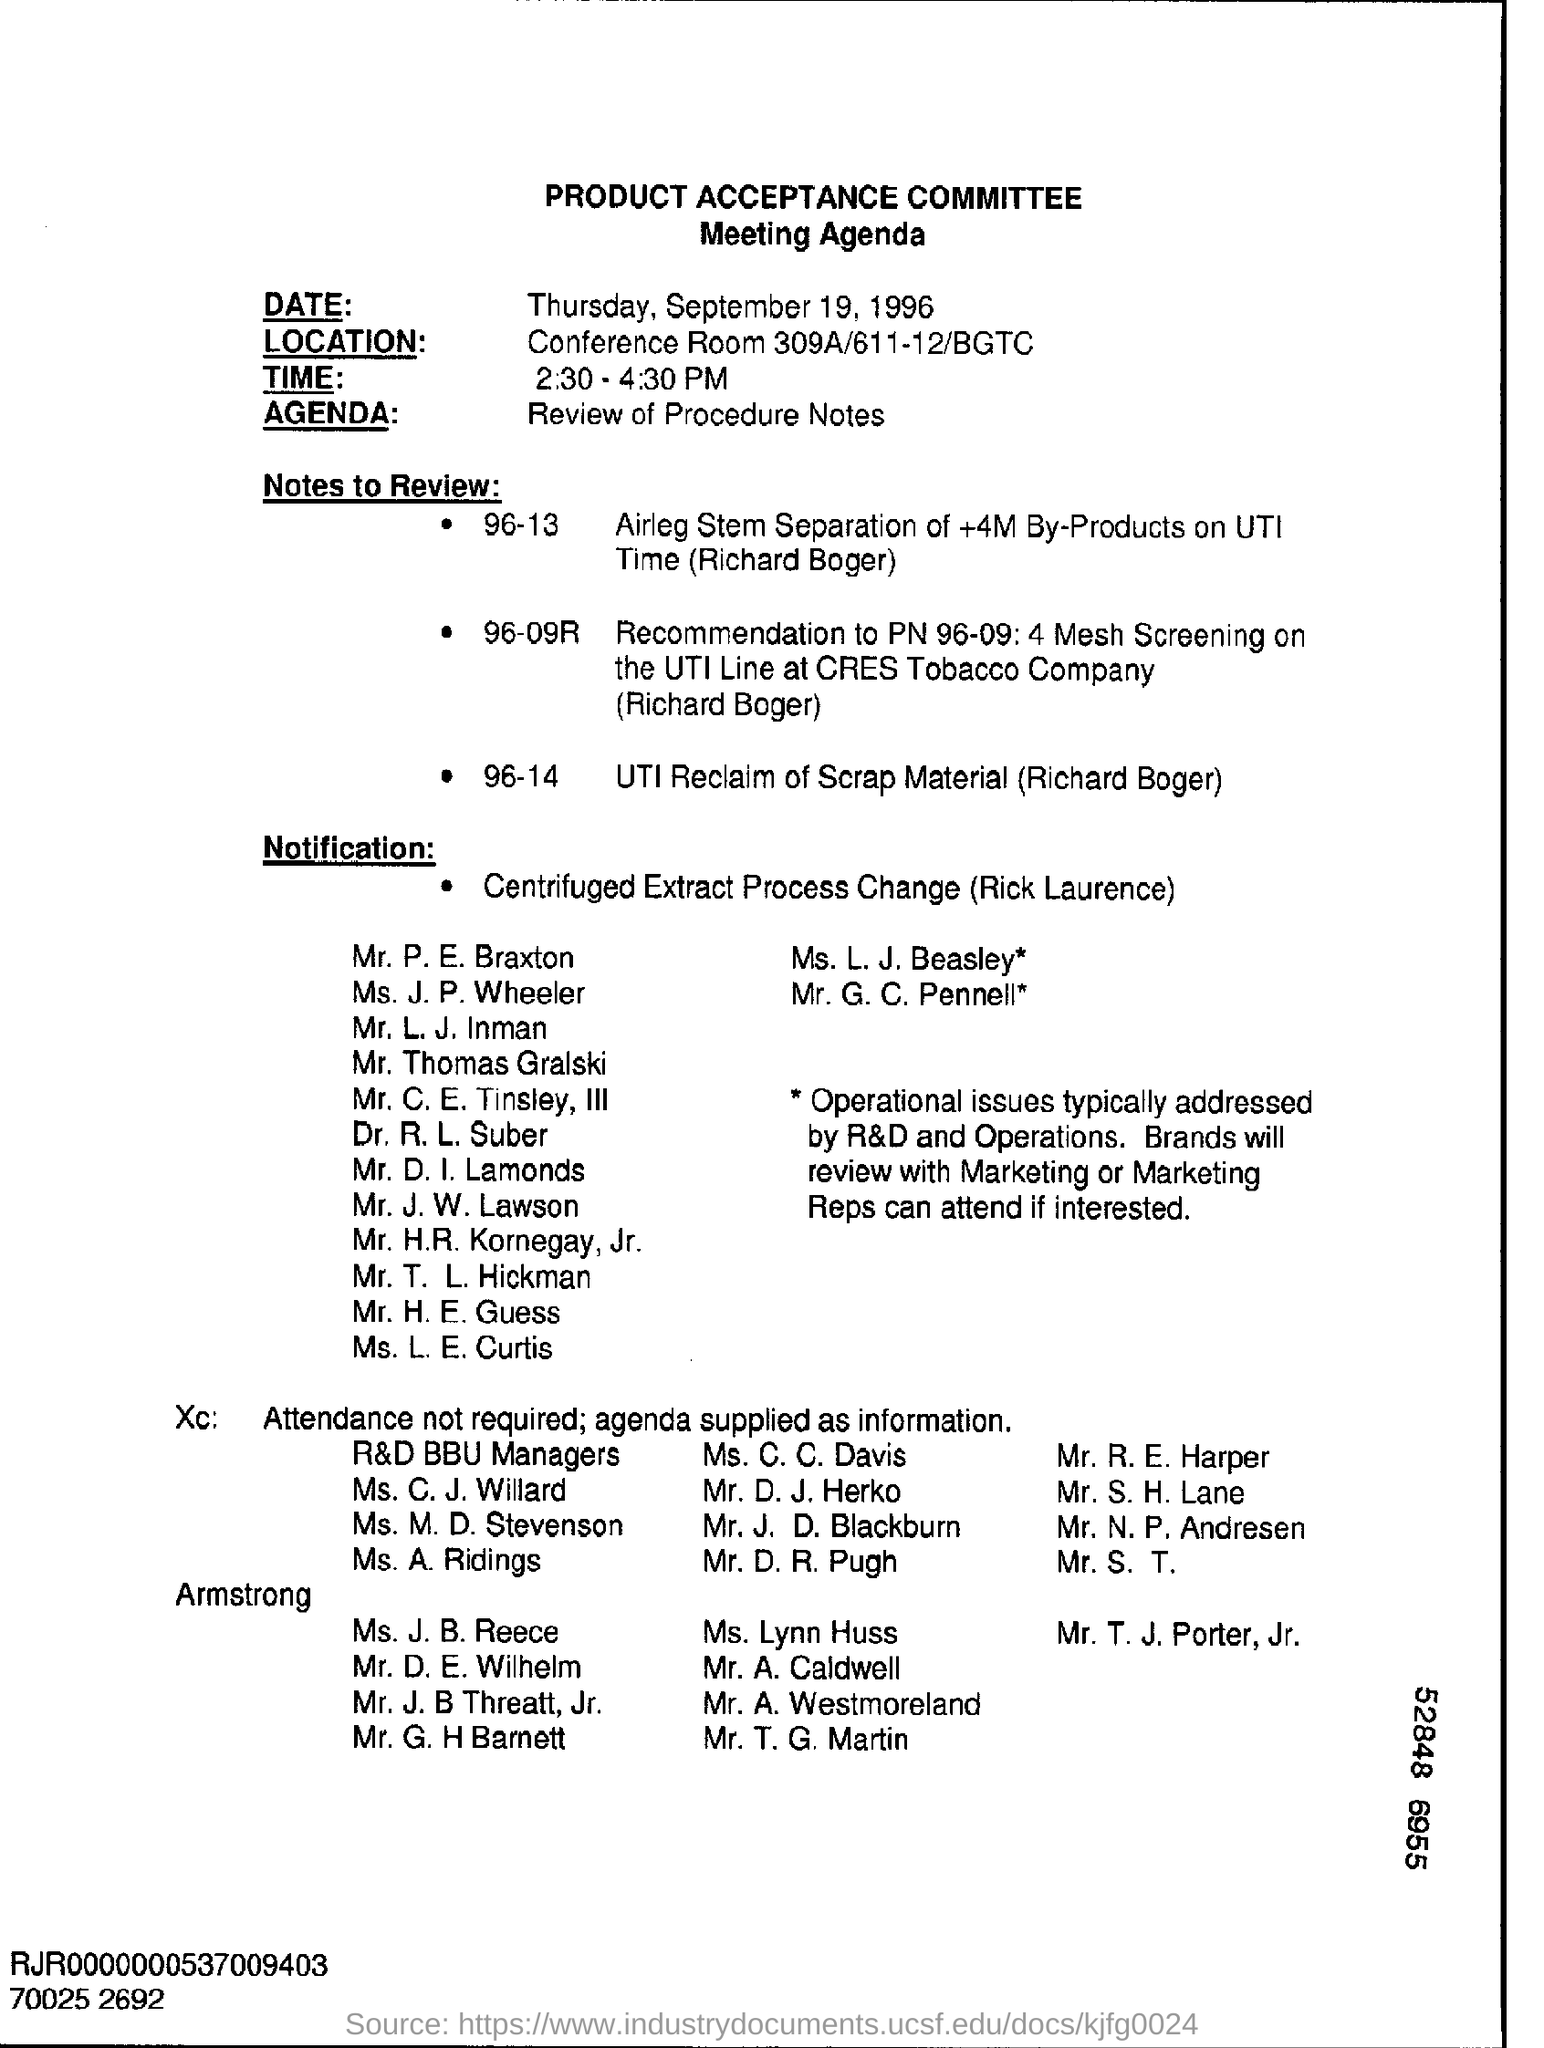Highlight a few significant elements in this photo. The agenda of the meeting is to review the procedure notes. 